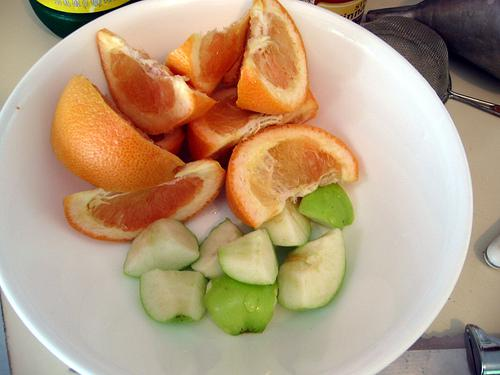Question: what other fruit is in the bowl?
Choices:
A. Oranges.
B. Apples.
C. Strawberries.
D. Bananas.
Answer with the letter. Answer: A Question: who is in the photo?
Choices:
A. Me.
B. My sister.
C. A dog.
D. Nobody.
Answer with the letter. Answer: D Question: where is the fruit?
Choices:
A. In my hand.
B. On the tree.
C. In the bowl.
D. In the refrigerator.
Answer with the letter. Answer: C Question: how many bowls are there?
Choices:
A. 7.
B. 1.
C. 8.
D. 9.
Answer with the letter. Answer: B Question: why is the fruit in the bowl?
Choices:
A. For art class drawing.
B. It needed a container.
C. To be served.
D. For storing.
Answer with the letter. Answer: C 